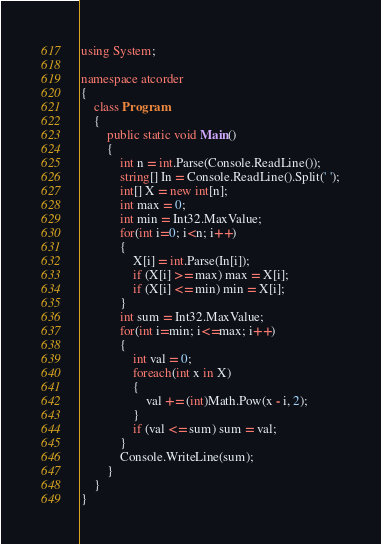Convert code to text. <code><loc_0><loc_0><loc_500><loc_500><_C#_>using System;

namespace atcorder
{
    class Program
    {
        public static void Main()
        {
            int n = int.Parse(Console.ReadLine());
            string[] In = Console.ReadLine().Split(' ');
            int[] X = new int[n];
            int max = 0;
            int min = Int32.MaxValue;
            for(int i=0; i<n; i++)
            {
                X[i] = int.Parse(In[i]);
                if (X[i] >= max) max = X[i];
                if (X[i] <= min) min = X[i];
            }
            int sum = Int32.MaxValue;
            for(int i=min; i<=max; i++)
            {
                int val = 0; 
                foreach(int x in X)
                {
                    val += (int)Math.Pow(x - i, 2);
                }
                if (val <= sum) sum = val;
            }
            Console.WriteLine(sum);
        }
    }
}
</code> 